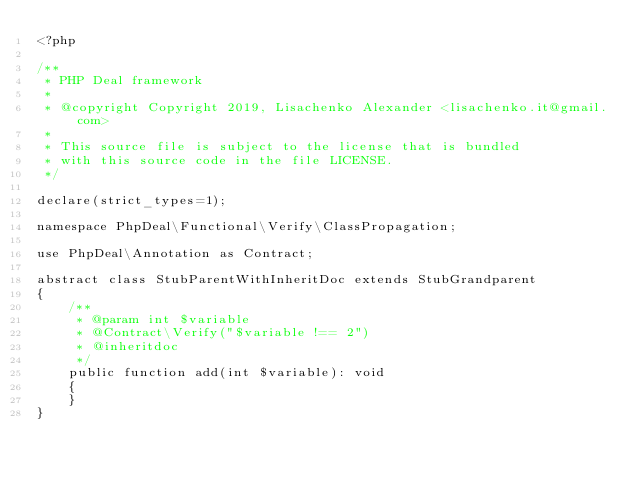<code> <loc_0><loc_0><loc_500><loc_500><_PHP_><?php

/**
 * PHP Deal framework
 *
 * @copyright Copyright 2019, Lisachenko Alexander <lisachenko.it@gmail.com>
 *
 * This source file is subject to the license that is bundled
 * with this source code in the file LICENSE.
 */

declare(strict_types=1);

namespace PhpDeal\Functional\Verify\ClassPropagation;

use PhpDeal\Annotation as Contract;

abstract class StubParentWithInheritDoc extends StubGrandparent
{
    /**
     * @param int $variable
     * @Contract\Verify("$variable !== 2")
     * @inheritdoc
     */
    public function add(int $variable): void
    {
    }
}
</code> 